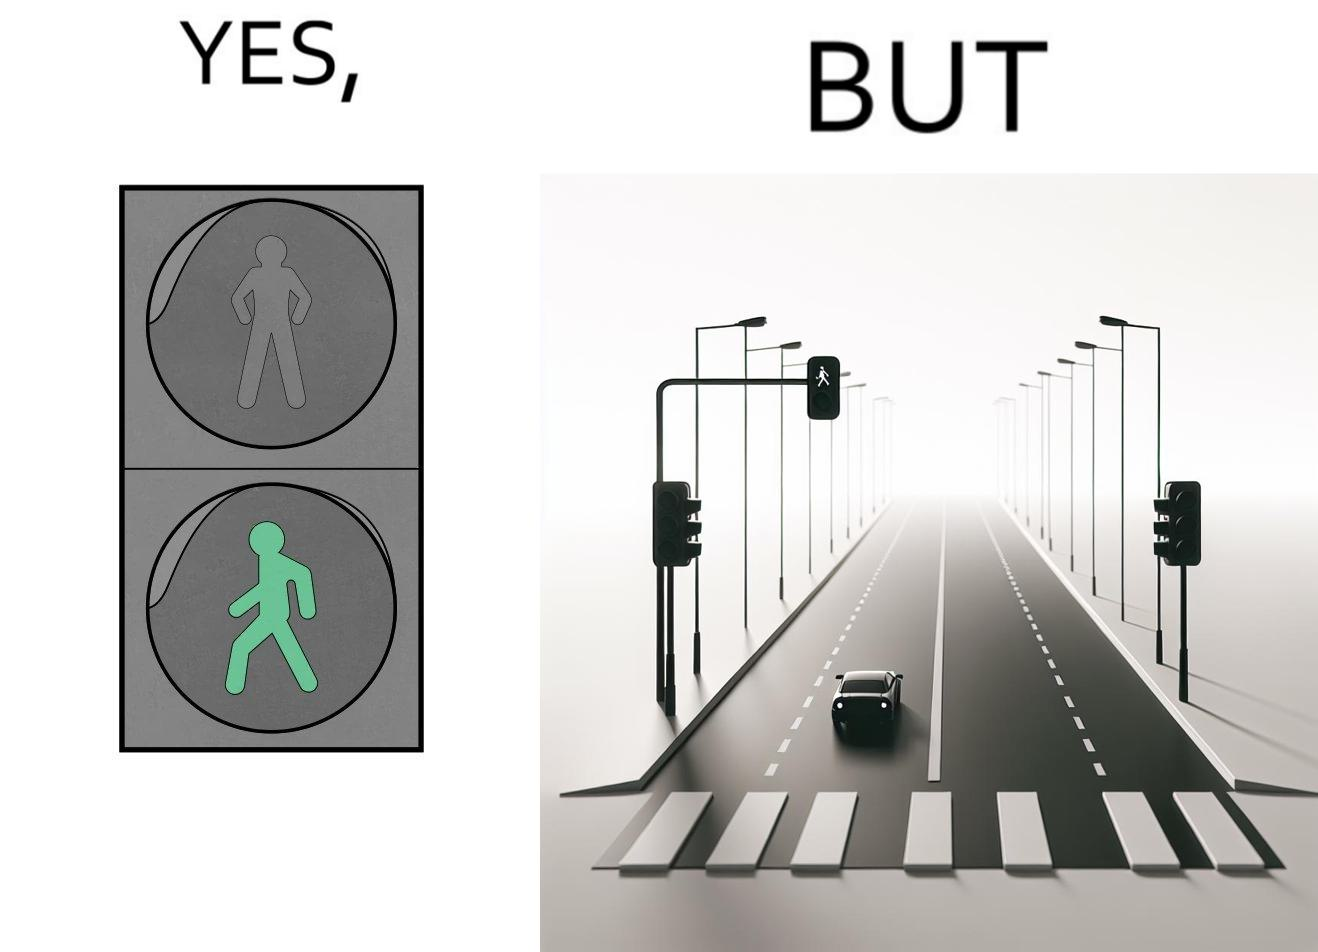Why is this image considered satirical? The image is funny because while walk signs are very useful for pedestrians to be able to cross roads safely, the become unnecessary and annoying for car drivers when these signals turn green even when there is no pedestrian tring to cross the road. 